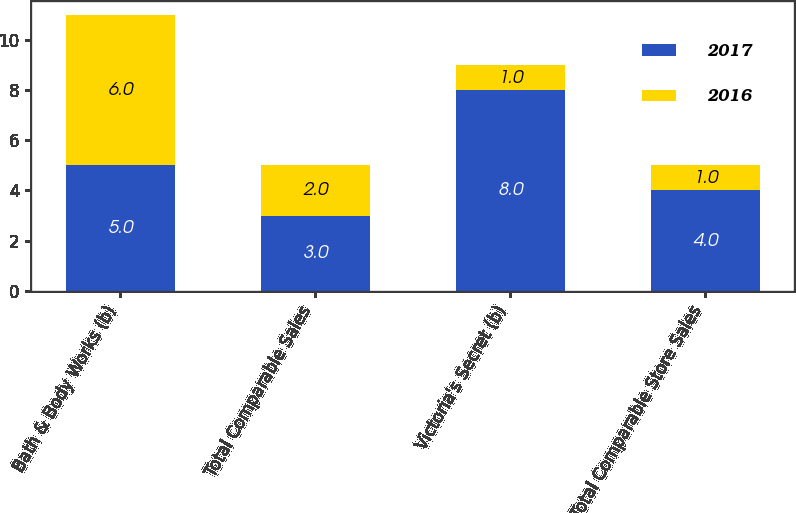Convert chart to OTSL. <chart><loc_0><loc_0><loc_500><loc_500><stacked_bar_chart><ecel><fcel>Bath & Body Works (b)<fcel>Total Comparable Sales<fcel>Victoria's Secret (b)<fcel>Total Comparable Store Sales<nl><fcel>2017<fcel>5<fcel>3<fcel>8<fcel>4<nl><fcel>2016<fcel>6<fcel>2<fcel>1<fcel>1<nl></chart> 